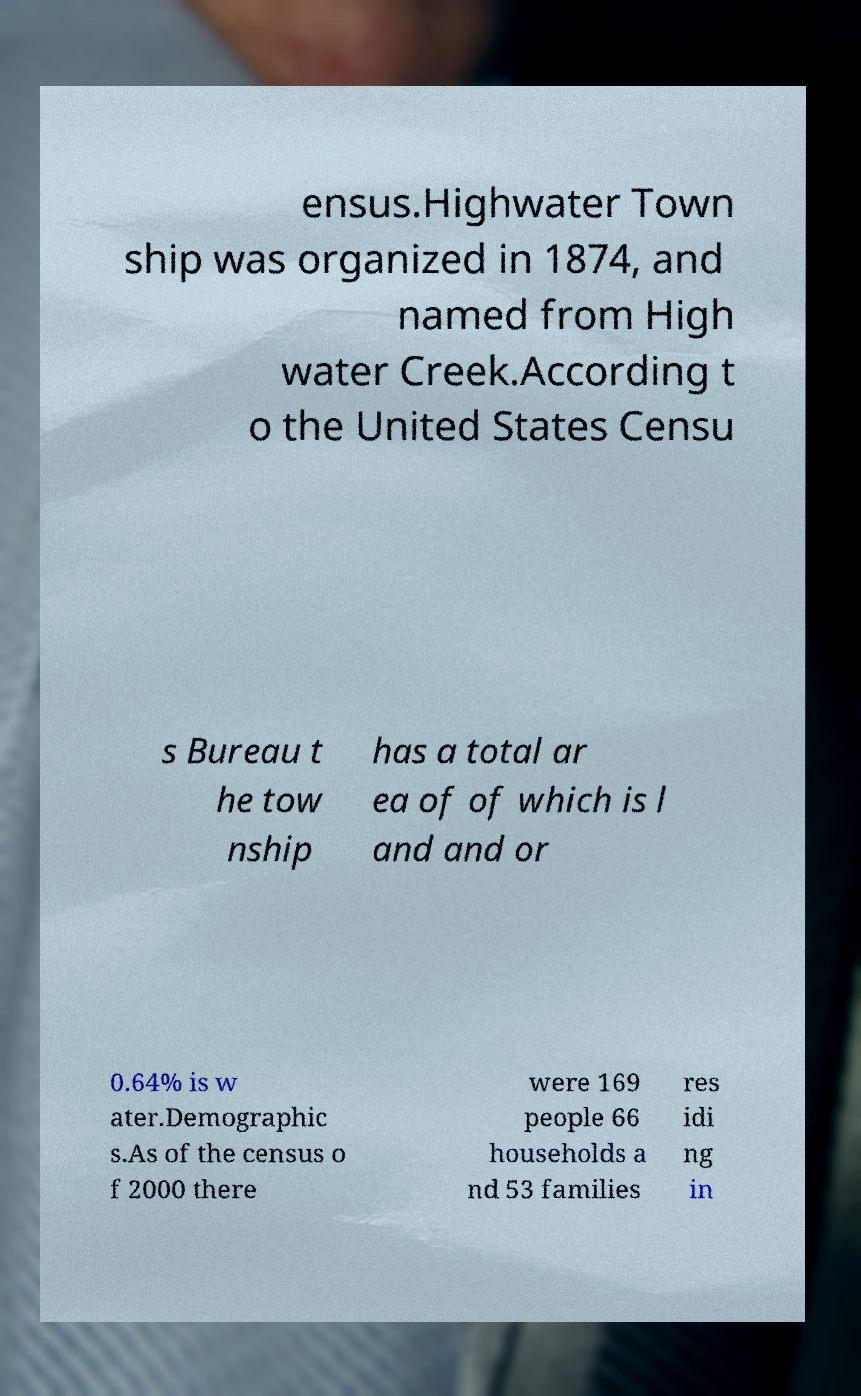Could you extract and type out the text from this image? ensus.Highwater Town ship was organized in 1874, and named from High water Creek.According t o the United States Censu s Bureau t he tow nship has a total ar ea of of which is l and and or 0.64% is w ater.Demographic s.As of the census o f 2000 there were 169 people 66 households a nd 53 families res idi ng in 